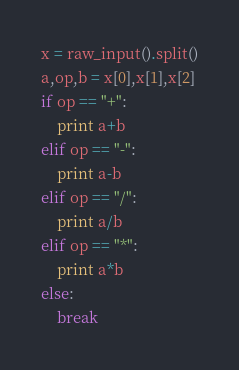<code> <loc_0><loc_0><loc_500><loc_500><_Python_>x = raw_input().split()
a,op,b = x[0],x[1],x[2]
if op == "+":
	print a+b
elif op == "-":
	print a-b
elif op == "/":
	print a/b
elif op == "*":
	print a*b
else:
	break</code> 